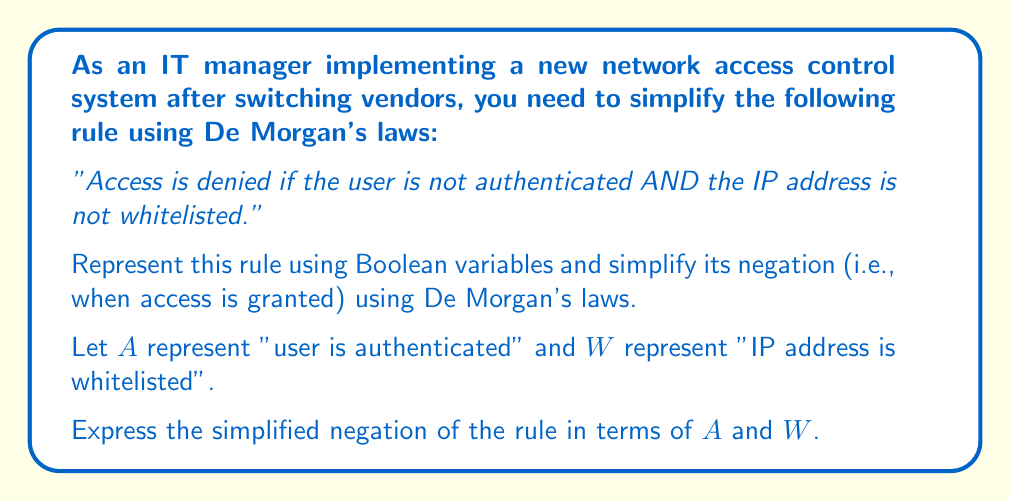Provide a solution to this math problem. Let's approach this step-by-step:

1) First, we need to represent the given rule using Boolean variables:
   Access is denied if: $\lnot A \land \lnot W$

2) We want to find when access is granted, which is the negation of this rule:
   $\lnot(\lnot A \land \lnot W)$

3) Now we can apply De Morgan's first law:
   $\lnot(P \land Q) \equiv \lnot P \lor \lnot Q$

4) Applying this to our expression:
   $\lnot(\lnot A \land \lnot W) \equiv \lnot(\lnot A) \lor \lnot(\lnot W)$

5) Simplify the double negations:
   $\lnot(\lnot A) \lor \lnot(\lnot W) \equiv A \lor W$

6) Therefore, the simplified negation of the rule (i.e., when access is granted) is:
   $A \lor W$

This means that access is granted if the user is authenticated OR the IP address is whitelisted.
Answer: $A \lor W$ 